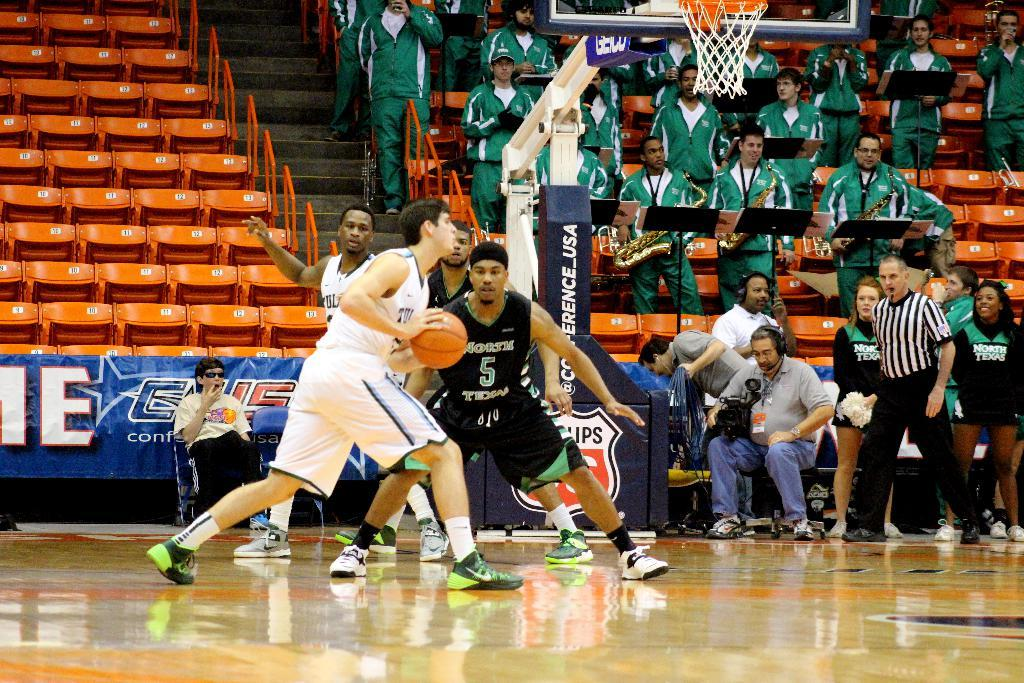<image>
Render a clear and concise summary of the photo. Basketball players playing on a court sponsored by Phillips 66. 